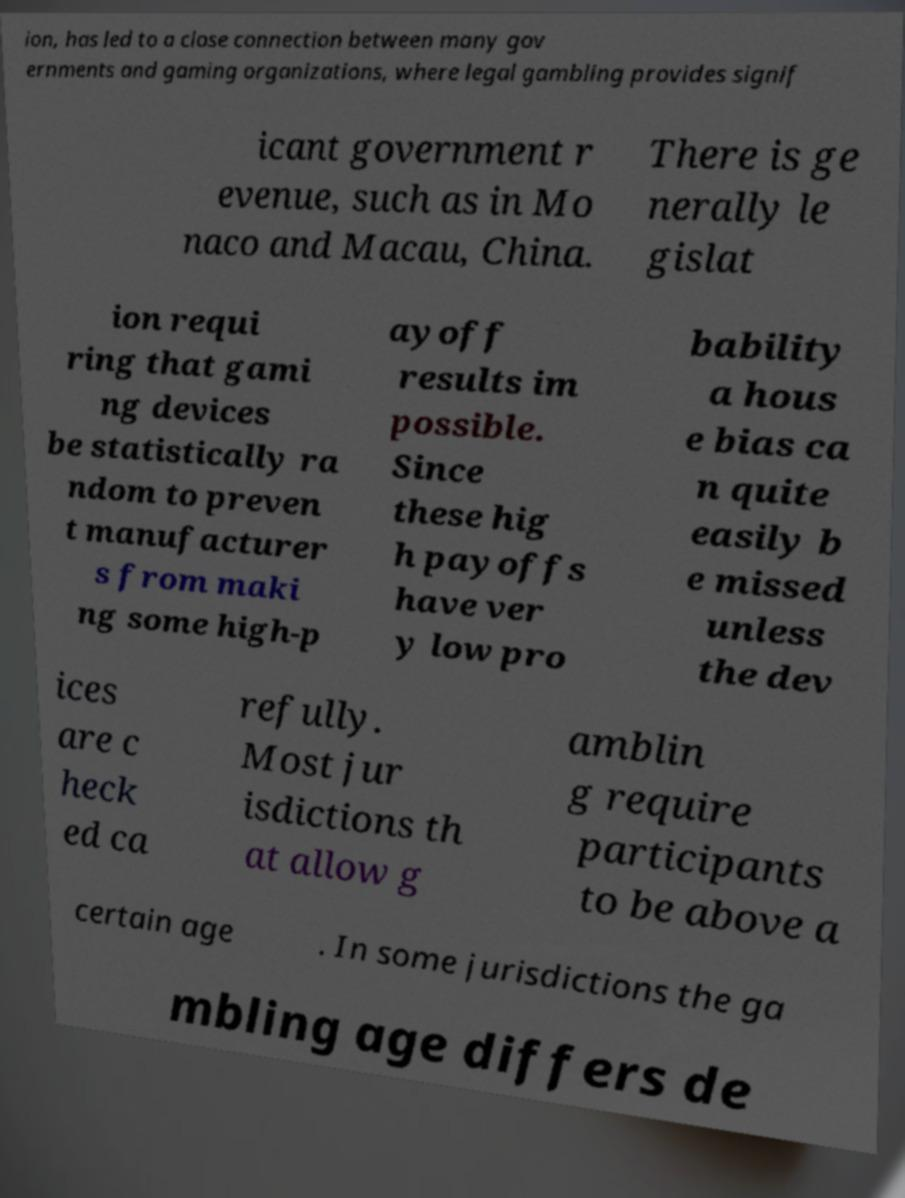For documentation purposes, I need the text within this image transcribed. Could you provide that? ion, has led to a close connection between many gov ernments and gaming organizations, where legal gambling provides signif icant government r evenue, such as in Mo naco and Macau, China. There is ge nerally le gislat ion requi ring that gami ng devices be statistically ra ndom to preven t manufacturer s from maki ng some high-p ayoff results im possible. Since these hig h payoffs have ver y low pro bability a hous e bias ca n quite easily b e missed unless the dev ices are c heck ed ca refully. Most jur isdictions th at allow g amblin g require participants to be above a certain age . In some jurisdictions the ga mbling age differs de 